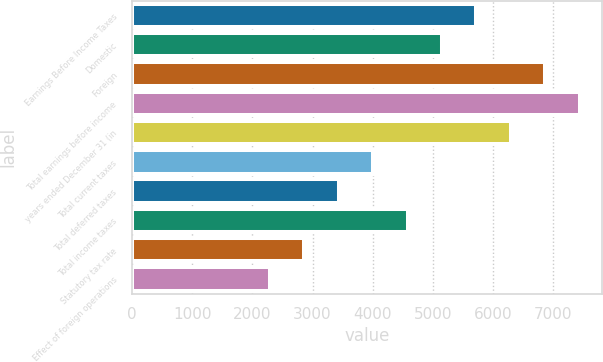<chart> <loc_0><loc_0><loc_500><loc_500><bar_chart><fcel>Earnings Before Income Taxes<fcel>Domestic<fcel>Foreign<fcel>Total earnings before income<fcel>years ended December 31 (in<fcel>Total current taxes<fcel>Total deferred taxes<fcel>Total income taxes<fcel>Statutory tax rate<fcel>Effect of foreign operations<nl><fcel>5725<fcel>5152.51<fcel>6869.98<fcel>7442.47<fcel>6297.49<fcel>4007.53<fcel>3435.04<fcel>4580.02<fcel>2862.55<fcel>2290.06<nl></chart> 